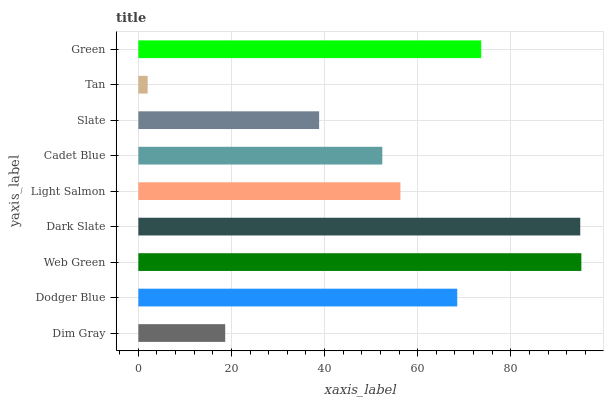Is Tan the minimum?
Answer yes or no. Yes. Is Web Green the maximum?
Answer yes or no. Yes. Is Dodger Blue the minimum?
Answer yes or no. No. Is Dodger Blue the maximum?
Answer yes or no. No. Is Dodger Blue greater than Dim Gray?
Answer yes or no. Yes. Is Dim Gray less than Dodger Blue?
Answer yes or no. Yes. Is Dim Gray greater than Dodger Blue?
Answer yes or no. No. Is Dodger Blue less than Dim Gray?
Answer yes or no. No. Is Light Salmon the high median?
Answer yes or no. Yes. Is Light Salmon the low median?
Answer yes or no. Yes. Is Green the high median?
Answer yes or no. No. Is Tan the low median?
Answer yes or no. No. 